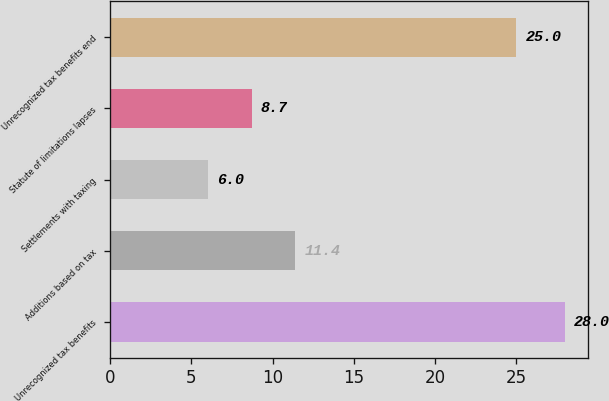<chart> <loc_0><loc_0><loc_500><loc_500><bar_chart><fcel>Unrecognized tax benefits<fcel>Additions based on tax<fcel>Settlements with taxing<fcel>Statute of limitations lapses<fcel>Unrecognized tax benefits end<nl><fcel>28<fcel>11.4<fcel>6<fcel>8.7<fcel>25<nl></chart> 